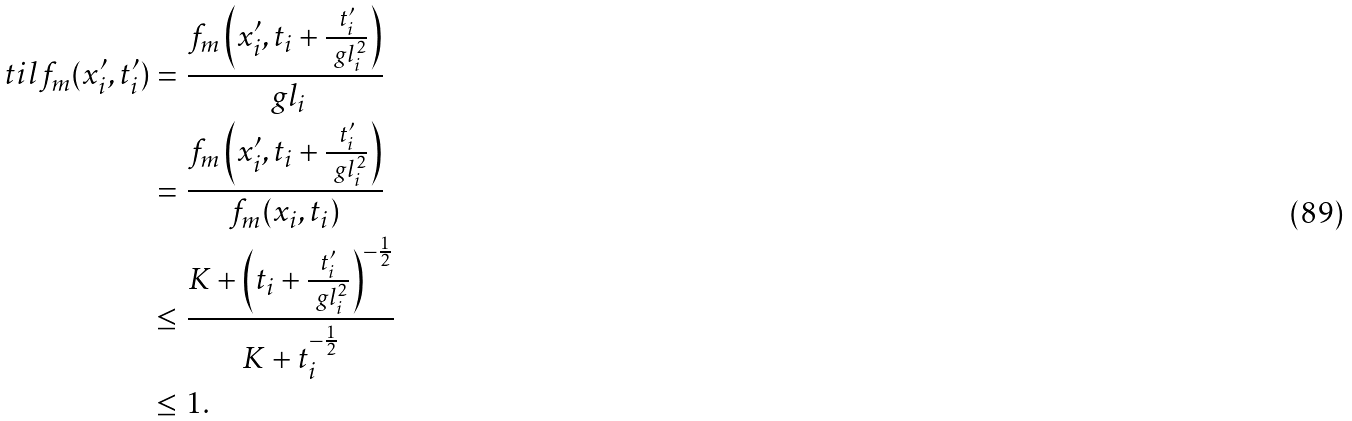Convert formula to latex. <formula><loc_0><loc_0><loc_500><loc_500>\ t i l { f } _ { m } ( x _ { i } ^ { \prime } , t _ { i } ^ { \prime } ) = & \ \frac { f _ { m } \left ( x _ { i } ^ { \prime } , t _ { i } + \frac { t _ { i } ^ { \prime } } { \ g l _ { i } ^ { 2 } } \right ) } { \ g l _ { i } } \\ = & \ \frac { f _ { m } \left ( x _ { i } ^ { \prime } , t _ { i } + \frac { t _ { i } ^ { \prime } } { \ g l _ { i } ^ { 2 } } \right ) } { f _ { m } ( x _ { i } , t _ { i } ) } \\ \leq & \ \frac { K + \left ( t _ { i } + \frac { t _ { i } ^ { \prime } } { \ g l _ { i } ^ { 2 } } \right ) ^ { - \frac { 1 } { 2 } } } { K + t _ { i } ^ { - \frac { 1 } { 2 } } } \\ \leq & \ 1 .</formula> 